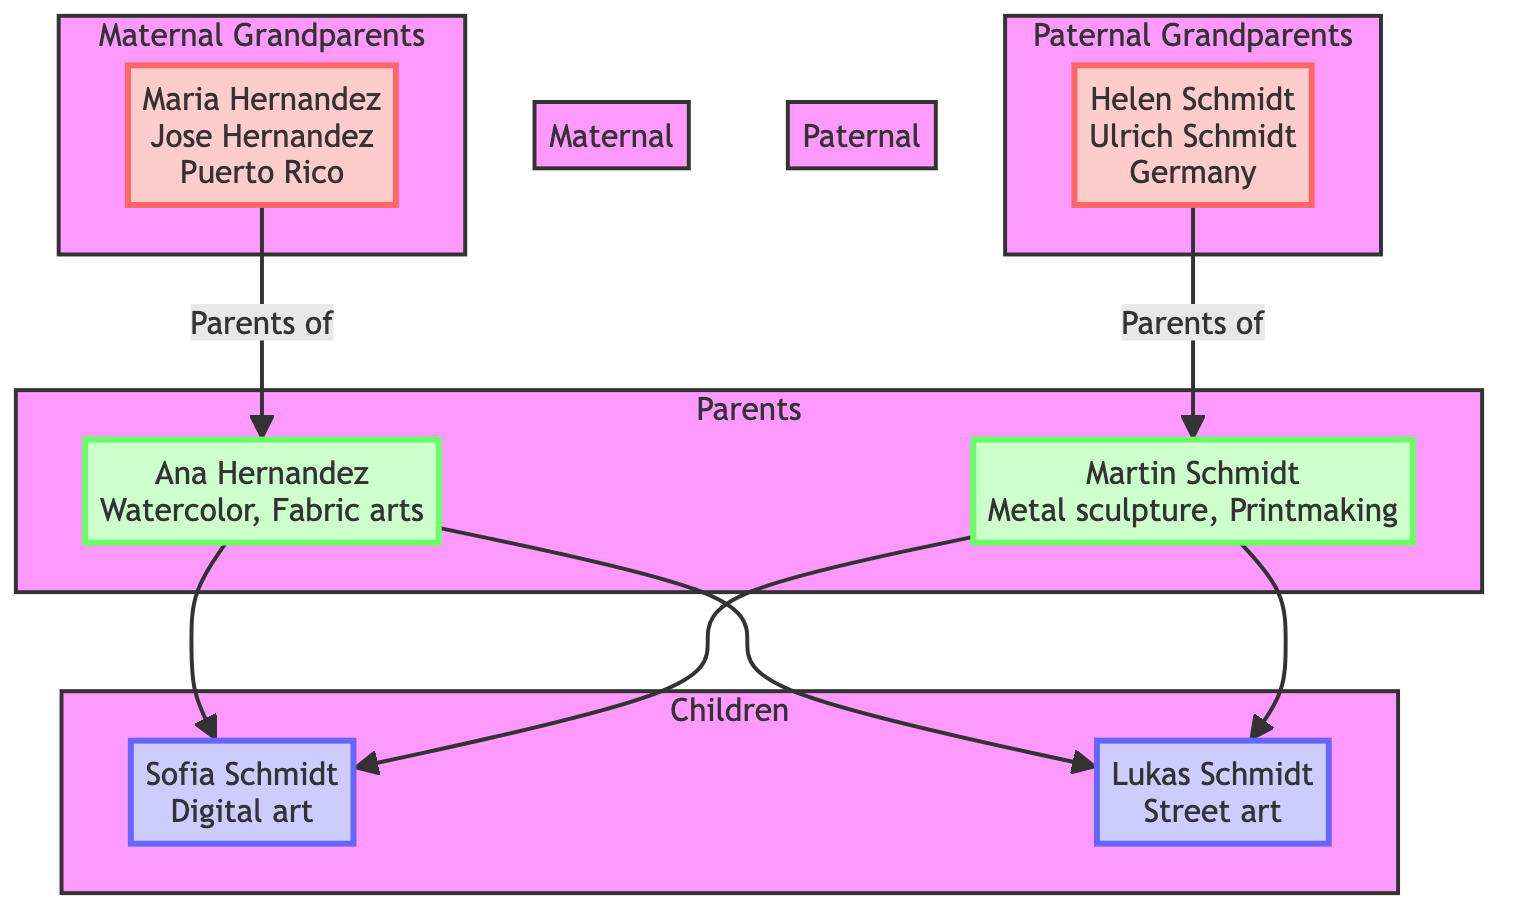What are the names of the maternal grandparents? The diagram lists the names of the maternal grandparents specifically as Maria Hernandez and Jose Hernandez. These names are directly taken from the node labeled "maternal_grandparents."
Answer: Maria Hernandez, Jose Hernandez Which country do the paternal grandparents originate from? Referring to the node for paternal grandparents, it indicates that their origin is Germany. This information is explicitly stated in the corresponding section of the diagram.
Answer: Germany How many artistic mediums does Ana Hernandez use? In the parents' section, under Ana Hernandez, it specifies the art mediums she uses: Watercolor and Fabric arts. Counting these, there are two different mediums listed.
Answer: 2 What shared artistic practice is represented in the diagram? The section that describes shared artistic practices lists "Collaborative mural painting" and "Mixed-media installations." Since the question asks for any of these practices, one can pick any stated practice.
Answer: Collaborative mural painting How many children do Martin Schmidt and Ana Hernandez have? Viewing the children section of the diagram, the names listed are Sofia Schmidt and Lukas Schmidt, indicating that there are two children in total.
Answer: 2 Which cultural celebration is associated with the maternal grandparents? The cultural traditions section for the maternal grandparents specifically mentions "Dia de los Reyes." This celebration is connected to their heritage and is clearly outlined in the diagram.
Answer: Dia de los Reyes What is the artistic influence brought by the paternal grandparents? The paternal grandparents section details artistic influences that include "Geometric abstraction" and "German folk art." The question requires one of these influences, so either can be selected.
Answer: Geometric abstraction What type of art do the children focus on? Looking at the children section, the emerging artistic trends mentioned are "Digital art" and "Street art." Selecting one of these established types of art fulfills the question.
Answer: Digital art What type of woodwork is identified in the paternal grandparents' artistic traditions? The diagram specifies that the paternal grandparents have a cultural tradition of "Woodcarving," which is explicitly stated in the art forms under their cultural traditions.
Answer: Woodcarving 